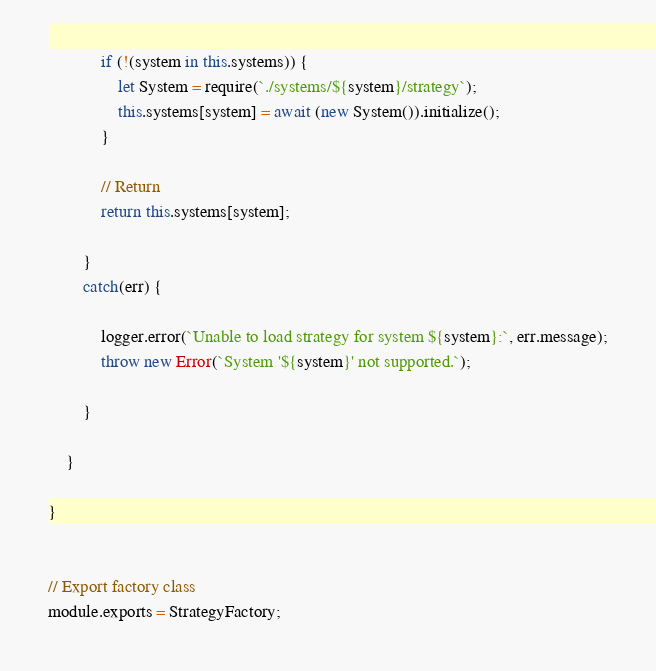<code> <loc_0><loc_0><loc_500><loc_500><_JavaScript_>            if (!(system in this.systems)) {
                let System = require(`./systems/${system}/strategy`);
                this.systems[system] = await (new System()).initialize();
            }

            // Return
            return this.systems[system];

        }
        catch(err) {

            logger.error(`Unable to load strategy for system ${system}:`, err.message);
            throw new Error(`System '${system}' not supported.`);

        }

    }

}


// Export factory class
module.exports = StrategyFactory;
</code> 